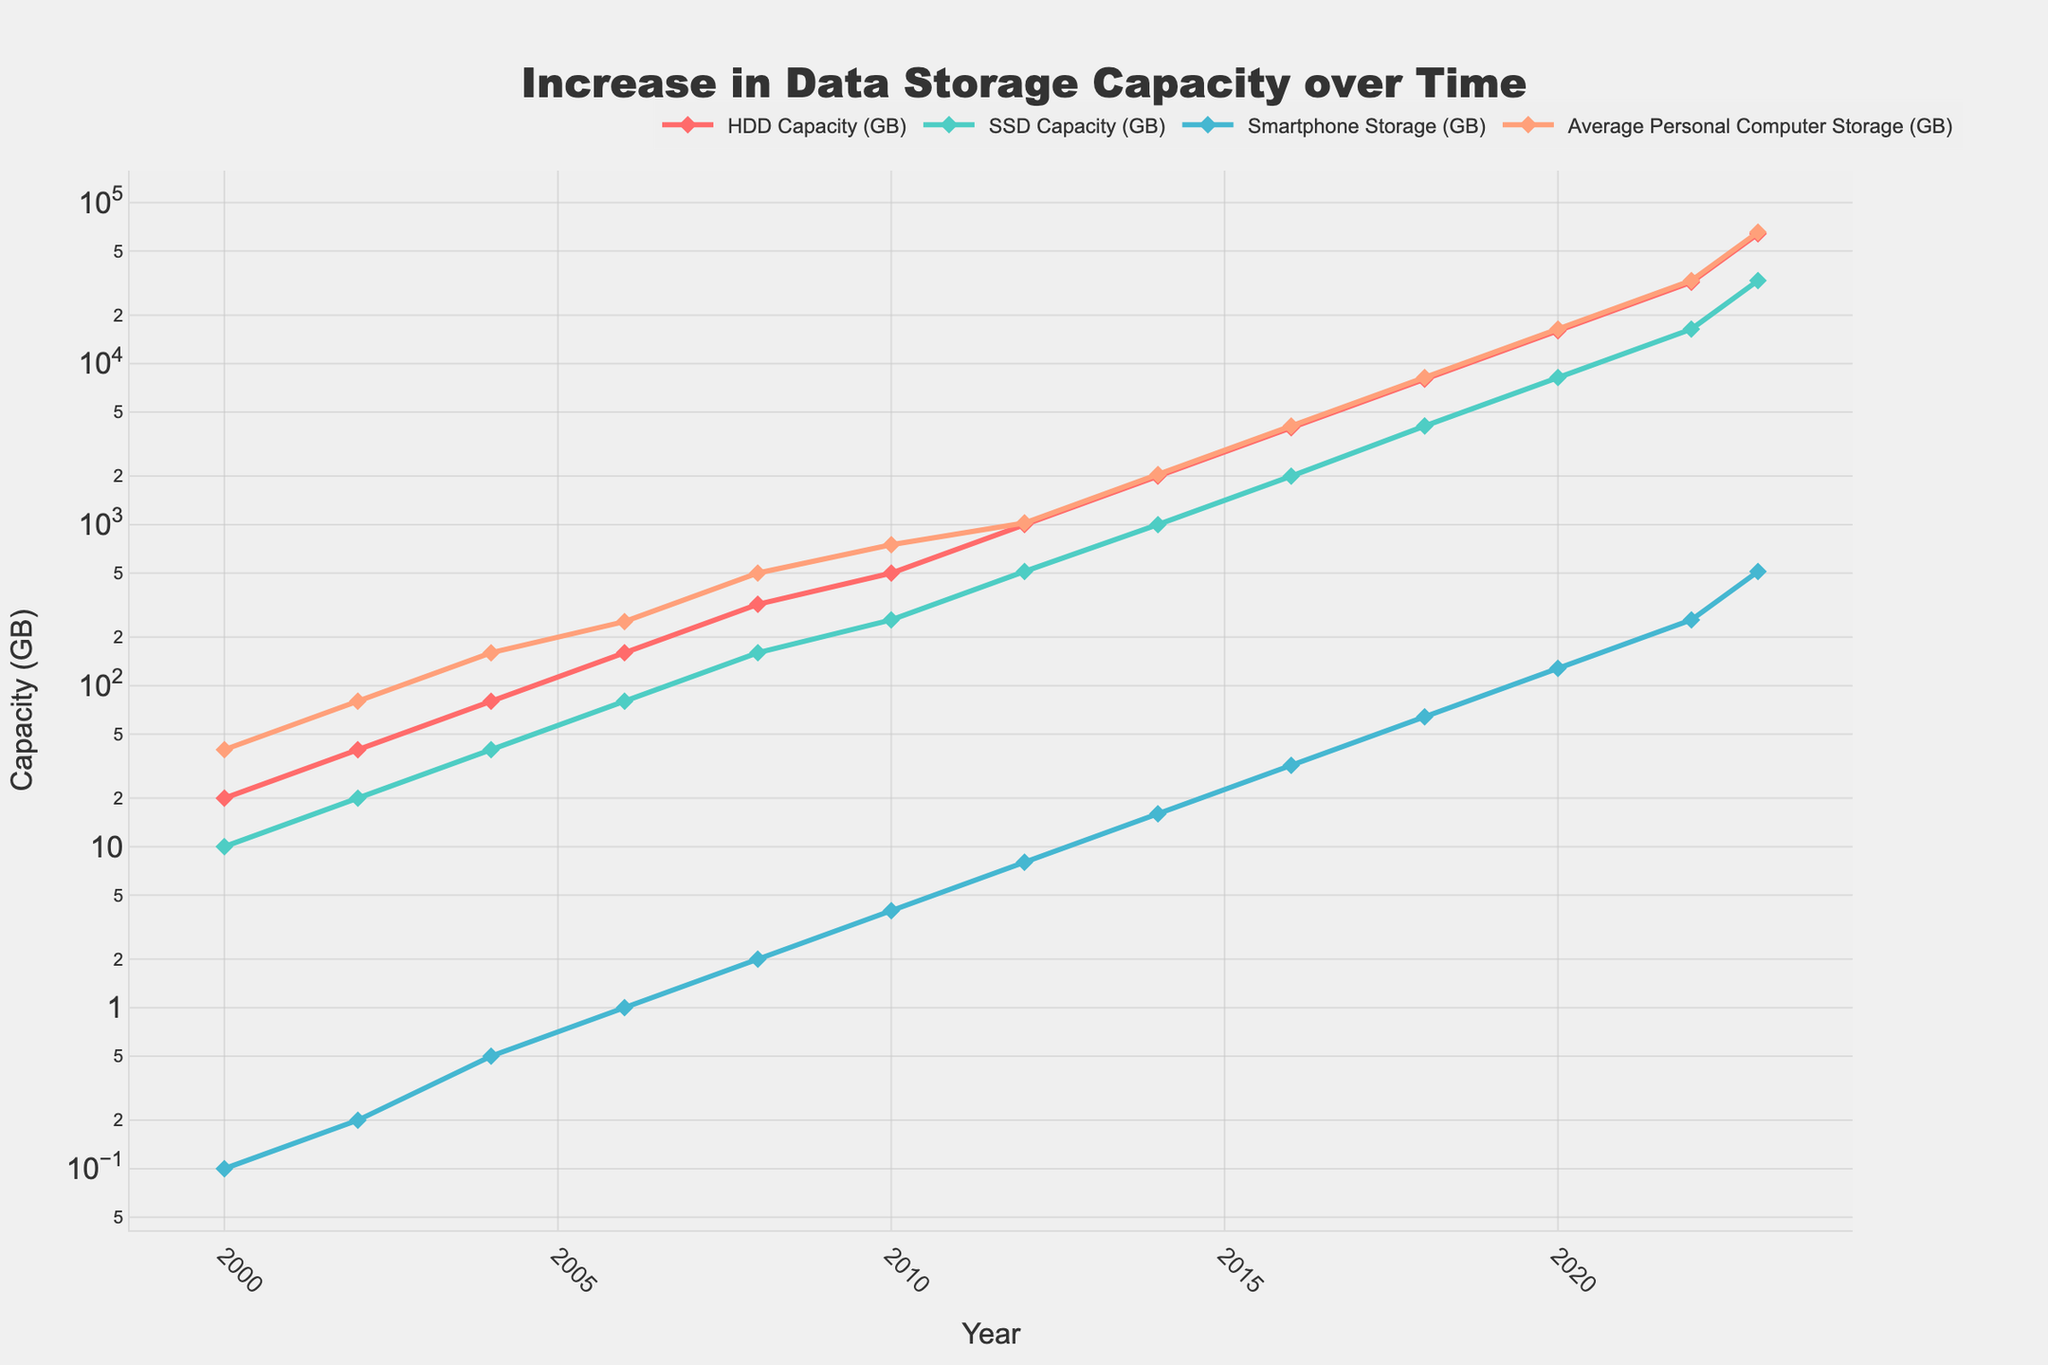What is the title of the plot? The title of the plot is provided at the top and states what the plot represents.
Answer: Increase in Data Storage Capacity over Time Which data storage type had the highest capacity in 2023? By examining the data points for the year 2023, we can see which line is highest on the plot.
Answer: Average Personal Computer Storage How did the SSD capacity change between 2006 and 2010? Look at the values of SSD capacity for the years 2006 and 2010 and calculate the difference between them.
Answer: Increased by 176 GB Which year showed the first instance of HDD capacity reaching 1 TB? Identify the year in the plot where the HDD line crosses the 1000 GB mark.
Answer: 2012 How does the capacity increase for smartphones from 2016 to 2020 compare to that from 2020 to 2023? Calculate the difference in smartphone storage between 2016 and 2020 and between 2020 and 2023 and compare the two values.
Answer: 96 GB vs 384 GB Which storage type has shown the fastest growth over the years? Observe the trend lines for all storage types and see which has the steepest increase.
Answer: Average Personal Computer Storage In which year did the smartphone storage reach 8 GB? Find the year where the line representing smartphone storage first hits the 8 GB mark.
Answer: 2012 What is the pattern of SSD capacity growth over the years? Evaluate the changes in the SSD capacity values to describe the growth pattern shown in the plot.
Answer: Exponential increase How many years did it take for HDD capacity to grow from 20 GB to 32000 GB? Identify the years corresponding to the 20 GB and the 32000 GB data points and calculate the difference between them.
Answer: 22 years Is the y-axis scaled linearly or logarithmically? Check the axis formatting to determine the type of scale used for the y-axis.
Answer: Logarithmically 